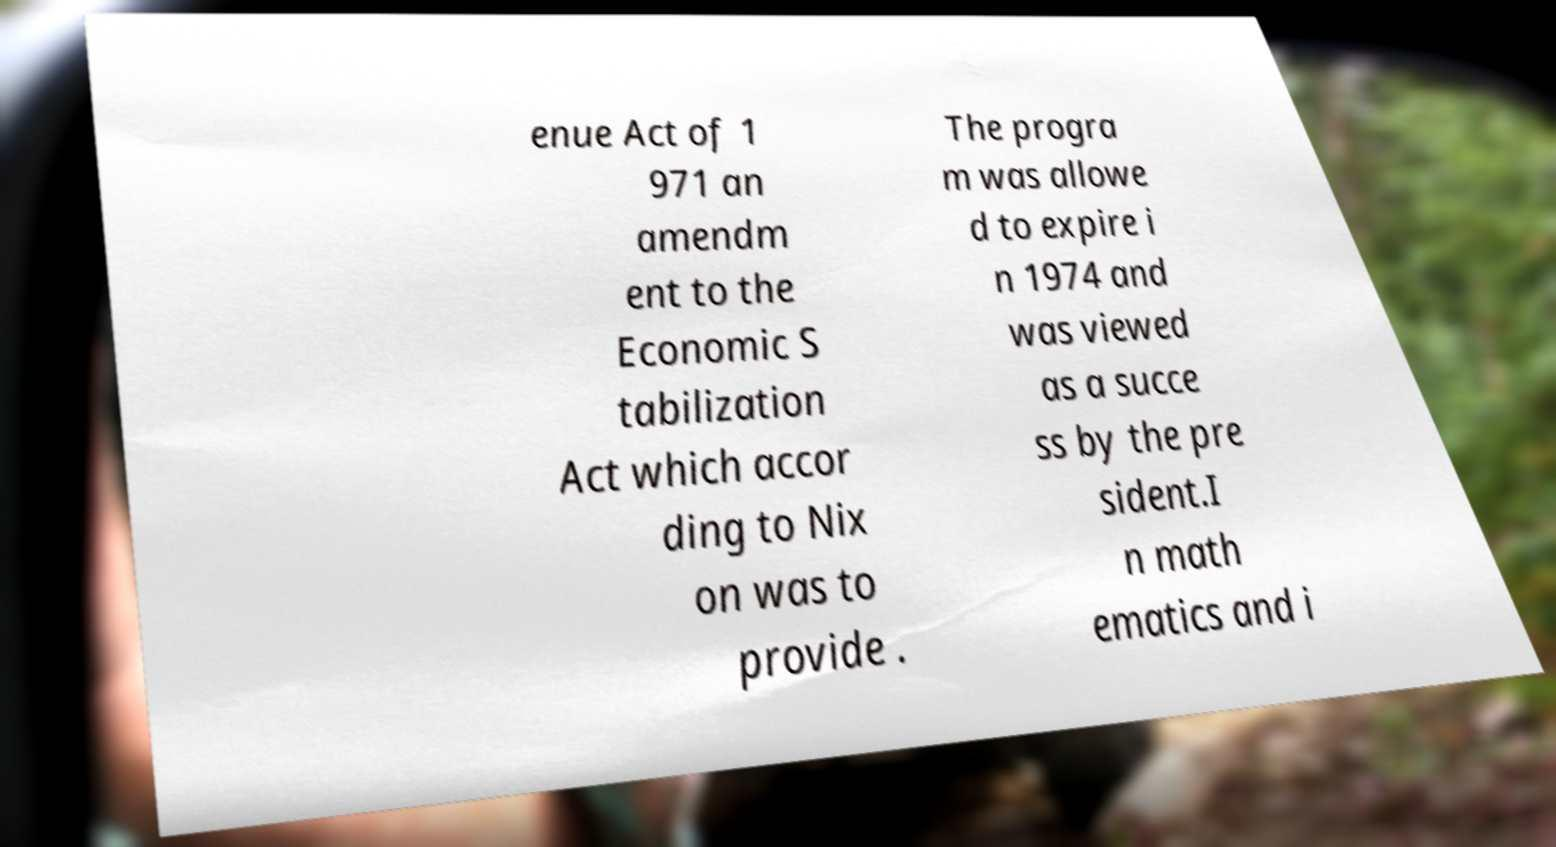There's text embedded in this image that I need extracted. Can you transcribe it verbatim? enue Act of 1 971 an amendm ent to the Economic S tabilization Act which accor ding to Nix on was to provide . The progra m was allowe d to expire i n 1974 and was viewed as a succe ss by the pre sident.I n math ematics and i 